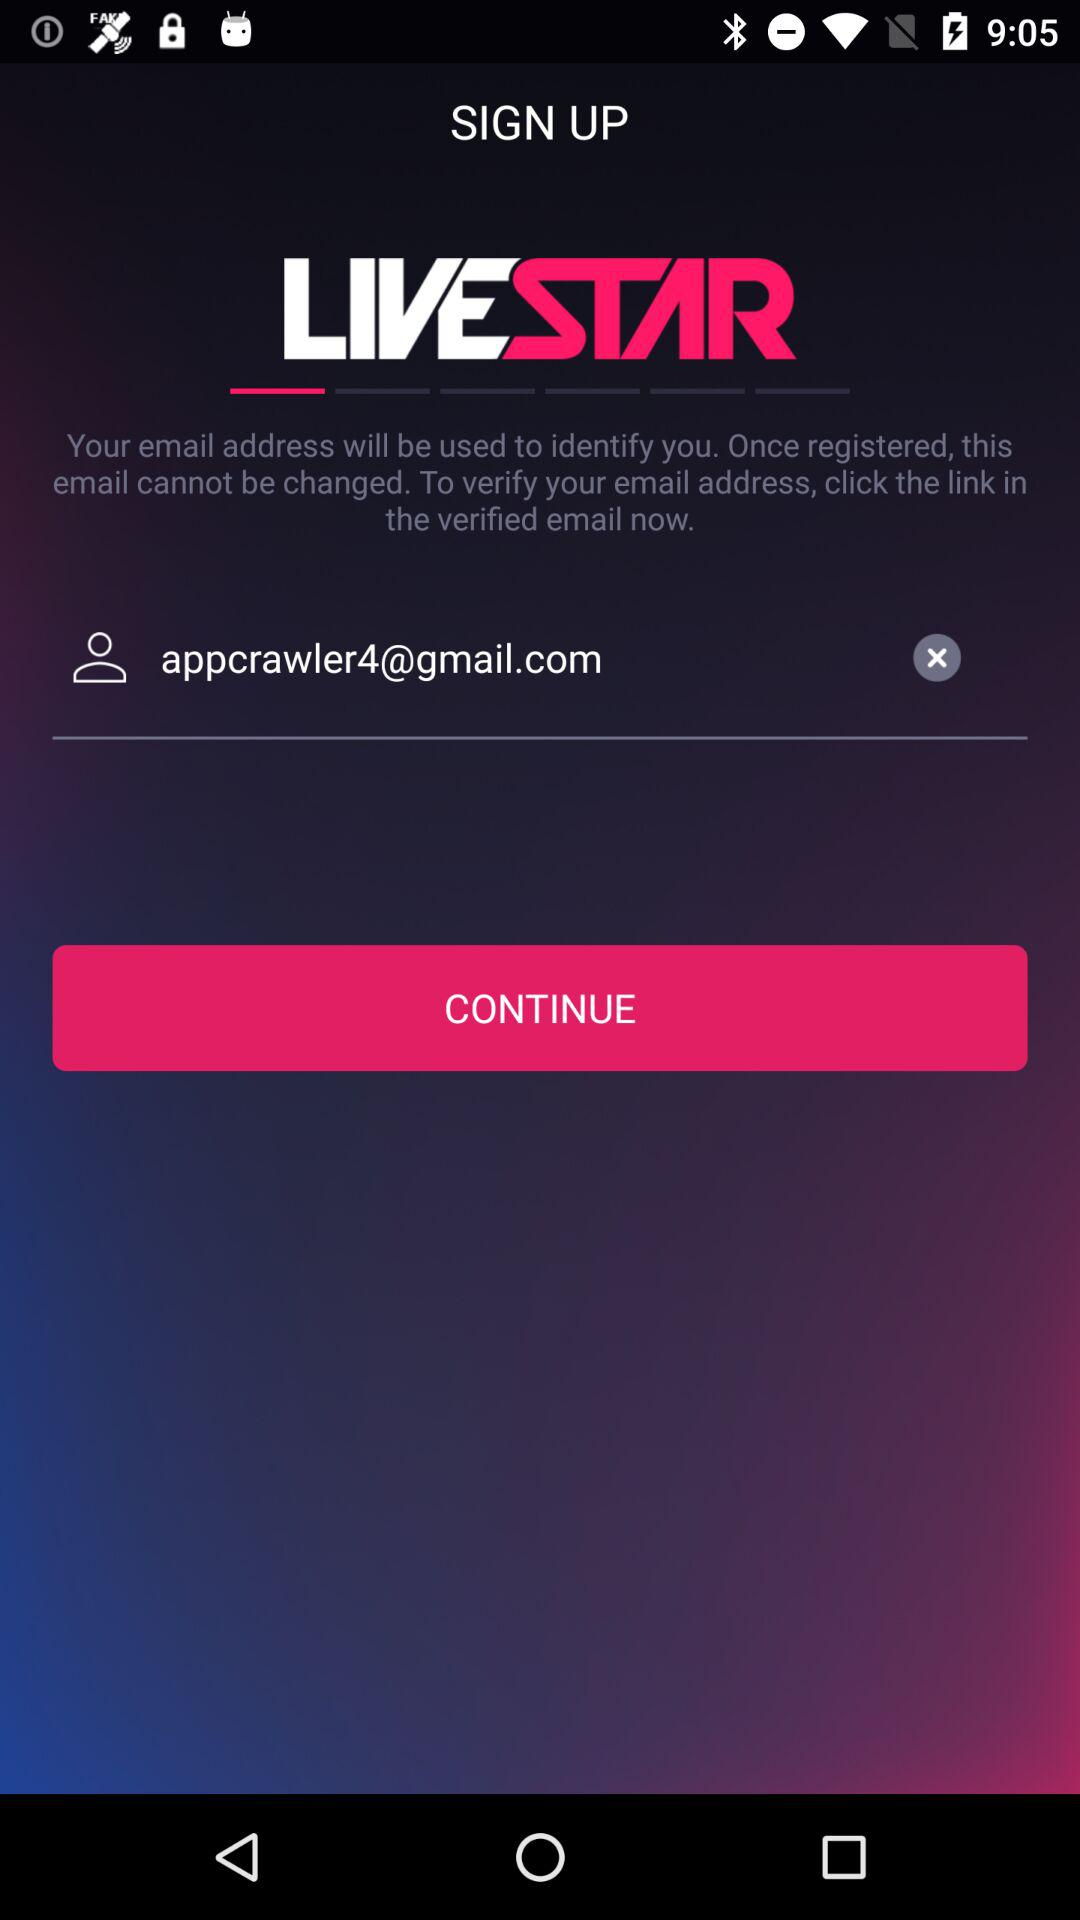What is the name of the application? The name of the application is "LIVESTAR". 